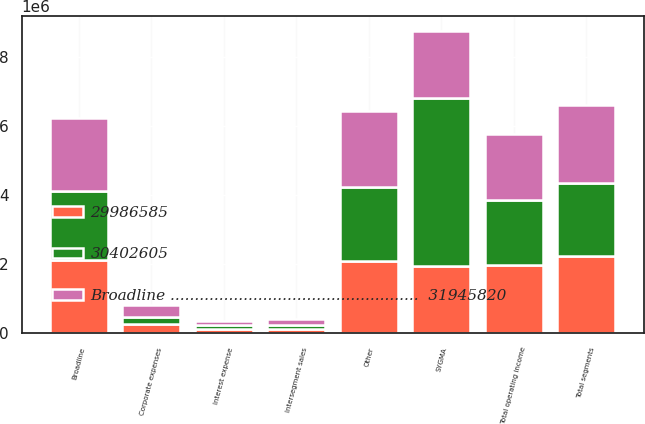Convert chart. <chart><loc_0><loc_0><loc_500><loc_500><stacked_bar_chart><ecel><fcel>SYGMA<fcel>Other<fcel>Intersegment sales<fcel>Broadline<fcel>Total segments<fcel>Corporate expenses<fcel>Total operating income<fcel>Interest expense<nl><fcel>Broadline ...................................................  31945820<fcel>1.95368e+06<fcel>2.19686e+06<fcel>160288<fcel>2.11613e+06<fcel>2.26864e+06<fcel>337133<fcel>1.9315e+06<fcel>118267<nl><fcel>29986585<fcel>1.95368e+06<fcel>2.09059e+06<fcel>140978<fcel>2.11392e+06<fcel>2.24544e+06<fcel>269573<fcel>1.97587e+06<fcel>125477<nl><fcel>30402605<fcel>4.83904e+06<fcel>2.13471e+06<fcel>106999<fcel>1.9964e+06<fcel>2.09151e+06<fcel>219300<fcel>1.87221e+06<fcel>116322<nl></chart> 